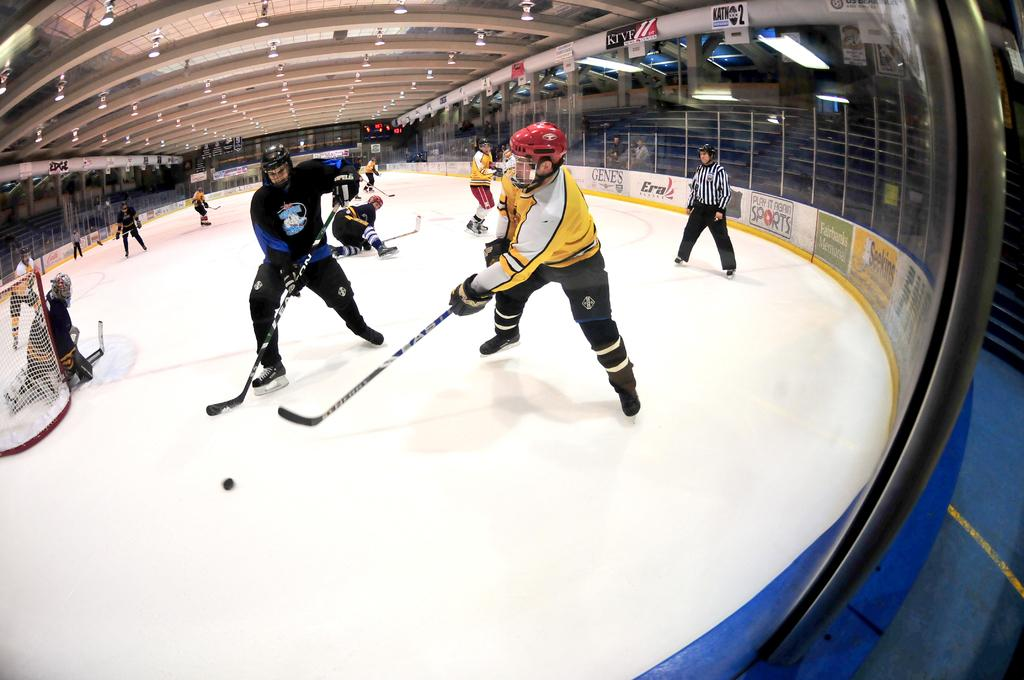What is the man in the image holding? The man is holding a bat in the image. What is the man trying to do with the bat? The man is trying to hit a ball with the bat. Are there any other people present in the image? Yes, there are other people standing nearby in the image. What is the purpose of the net in the image? The net is likely used to catch the ball after it is hit. What can be seen on the roof in the image? There are lights on the roof in the image. What type of leather is being used to make the swimsuits in the image? There is no swimsuit or leather present in the image; it features a man holding a bat and trying to hit a ball. 